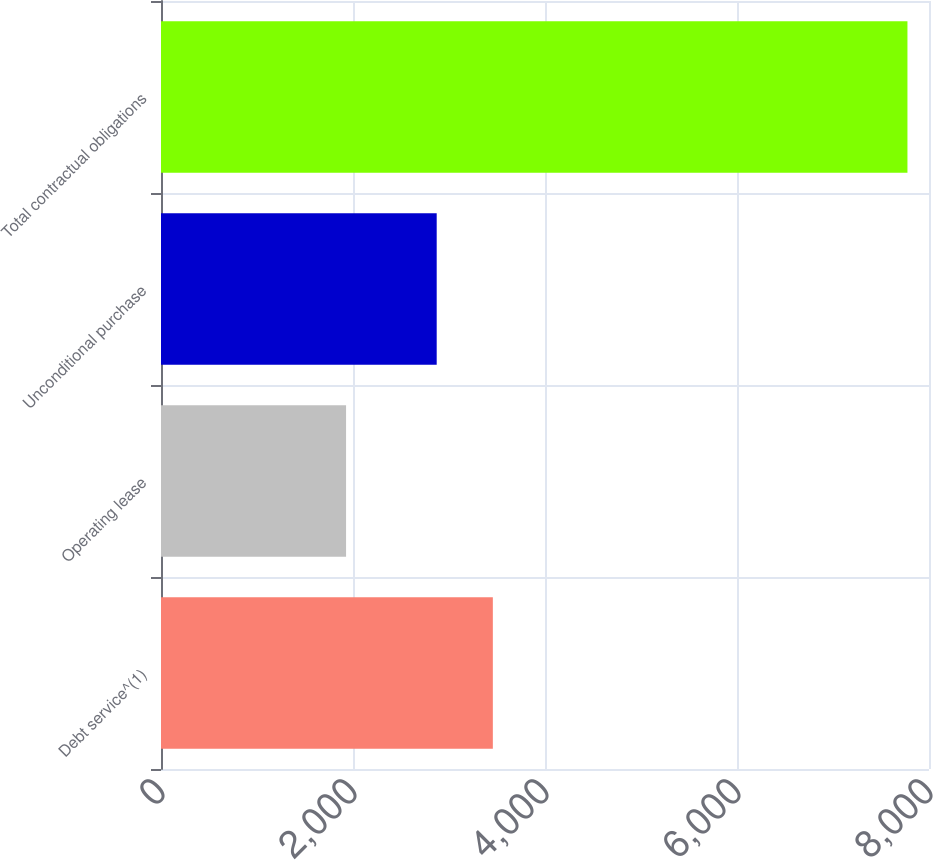Convert chart. <chart><loc_0><loc_0><loc_500><loc_500><bar_chart><fcel>Debt service^(1)<fcel>Operating lease<fcel>Unconditional purchase<fcel>Total contractual obligations<nl><fcel>3456.67<fcel>1927.8<fcel>2871.9<fcel>7775.5<nl></chart> 